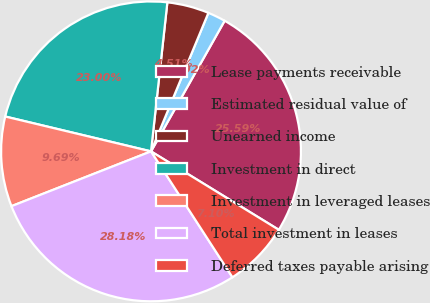<chart> <loc_0><loc_0><loc_500><loc_500><pie_chart><fcel>Lease payments receivable<fcel>Estimated residual value of<fcel>Unearned income<fcel>Investment in direct<fcel>Investment in leveraged leases<fcel>Total investment in leases<fcel>Deferred taxes payable arising<nl><fcel>25.59%<fcel>1.92%<fcel>4.51%<fcel>23.0%<fcel>9.69%<fcel>28.18%<fcel>7.1%<nl></chart> 